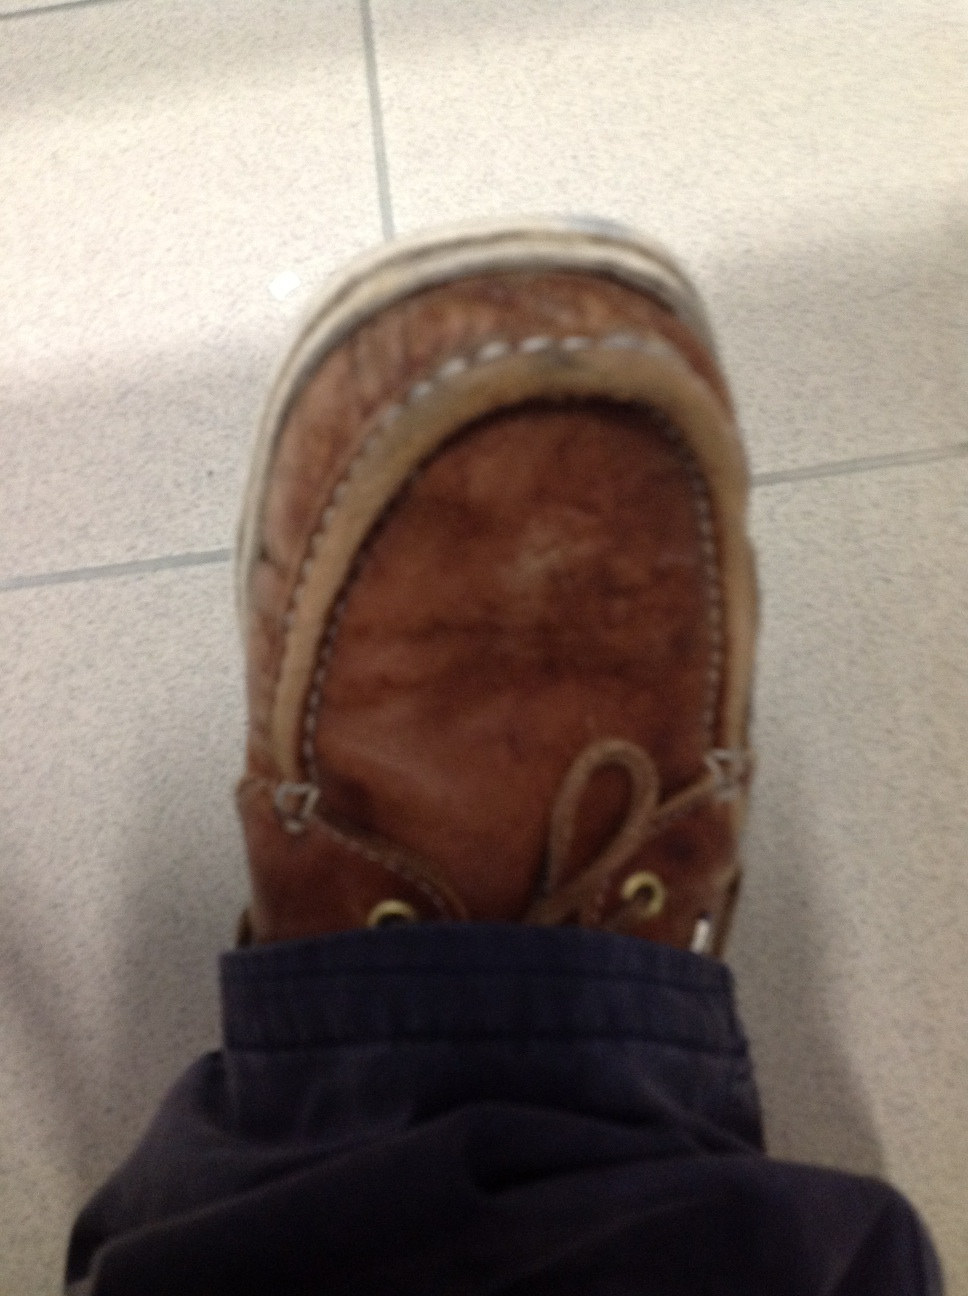How would this shoe fit into a futuristic society? In a futuristic society, this brown leather loafer might be seen as a vintage or retro fashion statement. It could be equipped with advanced features like built-in comfort cushioning adapted through nano-technology, self-cleaning leather surfaces, and embedded smart technology for tracking steps and health metrics. It would represent a blend of timeless style and cutting-edge innovation, sought after by those who appreciate both historical charm and modern convenience. 